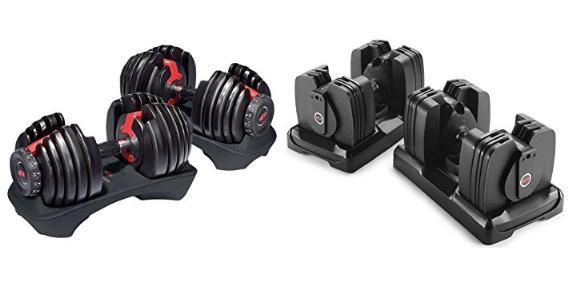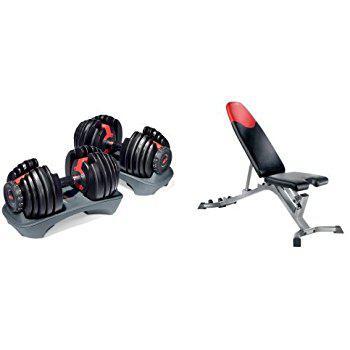The first image is the image on the left, the second image is the image on the right. Analyze the images presented: Is the assertion "The combined images include three dumbbell bars with weights on each end." valid? Answer yes or no. No. The first image is the image on the left, the second image is the image on the right. For the images displayed, is the sentence "The left and right image contains a total of three dumbbells." factually correct? Answer yes or no. No. 